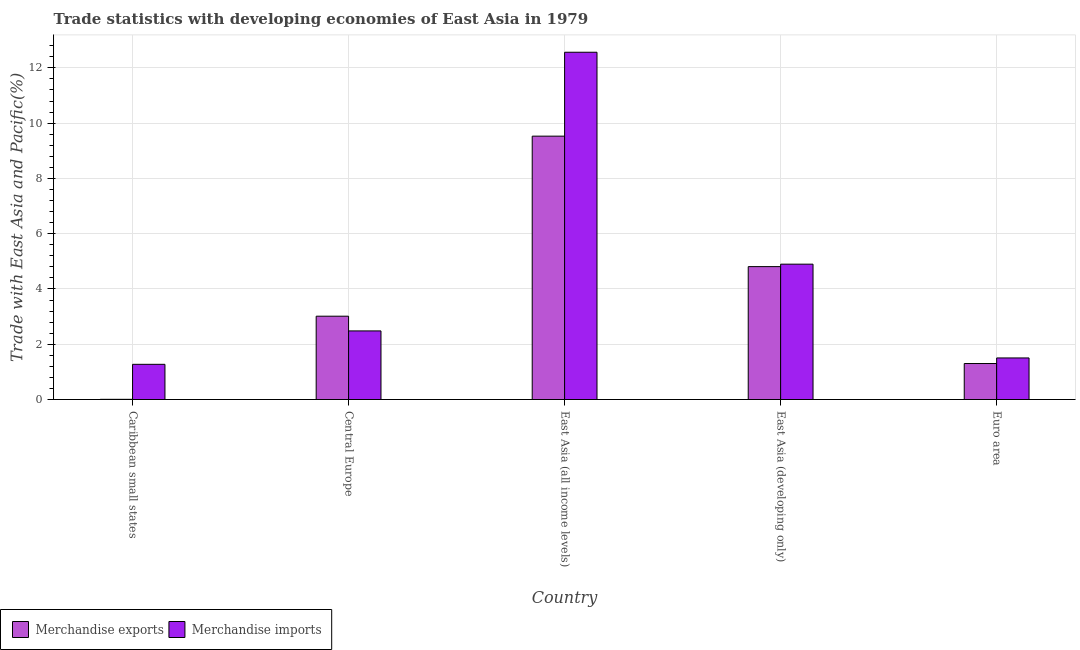Are the number of bars per tick equal to the number of legend labels?
Offer a terse response. Yes. Are the number of bars on each tick of the X-axis equal?
Make the answer very short. Yes. In how many cases, is the number of bars for a given country not equal to the number of legend labels?
Give a very brief answer. 0. What is the merchandise exports in Euro area?
Provide a short and direct response. 1.3. Across all countries, what is the maximum merchandise exports?
Ensure brevity in your answer.  9.53. Across all countries, what is the minimum merchandise exports?
Give a very brief answer. 0.01. In which country was the merchandise imports maximum?
Your answer should be compact. East Asia (all income levels). In which country was the merchandise imports minimum?
Offer a terse response. Caribbean small states. What is the total merchandise imports in the graph?
Provide a succinct answer. 22.72. What is the difference between the merchandise exports in Central Europe and that in Euro area?
Your answer should be very brief. 1.71. What is the difference between the merchandise imports in East Asia (all income levels) and the merchandise exports in Caribbean small states?
Your answer should be very brief. 12.56. What is the average merchandise exports per country?
Your answer should be very brief. 3.73. What is the difference between the merchandise exports and merchandise imports in Caribbean small states?
Your answer should be very brief. -1.27. What is the ratio of the merchandise imports in Caribbean small states to that in East Asia (all income levels)?
Give a very brief answer. 0.1. Is the merchandise exports in East Asia (developing only) less than that in Euro area?
Give a very brief answer. No. Is the difference between the merchandise exports in East Asia (all income levels) and East Asia (developing only) greater than the difference between the merchandise imports in East Asia (all income levels) and East Asia (developing only)?
Provide a succinct answer. No. What is the difference between the highest and the second highest merchandise imports?
Your answer should be compact. 7.67. What is the difference between the highest and the lowest merchandise imports?
Give a very brief answer. 11.29. In how many countries, is the merchandise exports greater than the average merchandise exports taken over all countries?
Make the answer very short. 2. How many bars are there?
Make the answer very short. 10. How many countries are there in the graph?
Provide a succinct answer. 5. Where does the legend appear in the graph?
Offer a very short reply. Bottom left. How many legend labels are there?
Your answer should be very brief. 2. How are the legend labels stacked?
Offer a very short reply. Horizontal. What is the title of the graph?
Provide a succinct answer. Trade statistics with developing economies of East Asia in 1979. What is the label or title of the X-axis?
Offer a terse response. Country. What is the label or title of the Y-axis?
Ensure brevity in your answer.  Trade with East Asia and Pacific(%). What is the Trade with East Asia and Pacific(%) in Merchandise exports in Caribbean small states?
Give a very brief answer. 0.01. What is the Trade with East Asia and Pacific(%) of Merchandise imports in Caribbean small states?
Your answer should be very brief. 1.27. What is the Trade with East Asia and Pacific(%) of Merchandise exports in Central Europe?
Keep it short and to the point. 3.02. What is the Trade with East Asia and Pacific(%) of Merchandise imports in Central Europe?
Provide a short and direct response. 2.48. What is the Trade with East Asia and Pacific(%) in Merchandise exports in East Asia (all income levels)?
Ensure brevity in your answer.  9.53. What is the Trade with East Asia and Pacific(%) in Merchandise imports in East Asia (all income levels)?
Your answer should be very brief. 12.57. What is the Trade with East Asia and Pacific(%) in Merchandise exports in East Asia (developing only)?
Offer a terse response. 4.81. What is the Trade with East Asia and Pacific(%) of Merchandise imports in East Asia (developing only)?
Provide a short and direct response. 4.9. What is the Trade with East Asia and Pacific(%) in Merchandise exports in Euro area?
Your answer should be very brief. 1.3. What is the Trade with East Asia and Pacific(%) in Merchandise imports in Euro area?
Offer a terse response. 1.5. Across all countries, what is the maximum Trade with East Asia and Pacific(%) in Merchandise exports?
Offer a terse response. 9.53. Across all countries, what is the maximum Trade with East Asia and Pacific(%) of Merchandise imports?
Make the answer very short. 12.57. Across all countries, what is the minimum Trade with East Asia and Pacific(%) in Merchandise exports?
Your response must be concise. 0.01. Across all countries, what is the minimum Trade with East Asia and Pacific(%) in Merchandise imports?
Make the answer very short. 1.27. What is the total Trade with East Asia and Pacific(%) of Merchandise exports in the graph?
Ensure brevity in your answer.  18.66. What is the total Trade with East Asia and Pacific(%) in Merchandise imports in the graph?
Ensure brevity in your answer.  22.72. What is the difference between the Trade with East Asia and Pacific(%) in Merchandise exports in Caribbean small states and that in Central Europe?
Your answer should be compact. -3.01. What is the difference between the Trade with East Asia and Pacific(%) of Merchandise imports in Caribbean small states and that in Central Europe?
Ensure brevity in your answer.  -1.21. What is the difference between the Trade with East Asia and Pacific(%) of Merchandise exports in Caribbean small states and that in East Asia (all income levels)?
Keep it short and to the point. -9.52. What is the difference between the Trade with East Asia and Pacific(%) in Merchandise imports in Caribbean small states and that in East Asia (all income levels)?
Keep it short and to the point. -11.29. What is the difference between the Trade with East Asia and Pacific(%) of Merchandise exports in Caribbean small states and that in East Asia (developing only)?
Your response must be concise. -4.8. What is the difference between the Trade with East Asia and Pacific(%) in Merchandise imports in Caribbean small states and that in East Asia (developing only)?
Give a very brief answer. -3.62. What is the difference between the Trade with East Asia and Pacific(%) of Merchandise exports in Caribbean small states and that in Euro area?
Offer a very short reply. -1.3. What is the difference between the Trade with East Asia and Pacific(%) of Merchandise imports in Caribbean small states and that in Euro area?
Your answer should be compact. -0.23. What is the difference between the Trade with East Asia and Pacific(%) of Merchandise exports in Central Europe and that in East Asia (all income levels)?
Your response must be concise. -6.51. What is the difference between the Trade with East Asia and Pacific(%) of Merchandise imports in Central Europe and that in East Asia (all income levels)?
Make the answer very short. -10.08. What is the difference between the Trade with East Asia and Pacific(%) of Merchandise exports in Central Europe and that in East Asia (developing only)?
Offer a very short reply. -1.79. What is the difference between the Trade with East Asia and Pacific(%) in Merchandise imports in Central Europe and that in East Asia (developing only)?
Provide a short and direct response. -2.41. What is the difference between the Trade with East Asia and Pacific(%) of Merchandise exports in Central Europe and that in Euro area?
Offer a very short reply. 1.71. What is the difference between the Trade with East Asia and Pacific(%) of Merchandise imports in Central Europe and that in Euro area?
Your response must be concise. 0.98. What is the difference between the Trade with East Asia and Pacific(%) of Merchandise exports in East Asia (all income levels) and that in East Asia (developing only)?
Your answer should be very brief. 4.72. What is the difference between the Trade with East Asia and Pacific(%) in Merchandise imports in East Asia (all income levels) and that in East Asia (developing only)?
Your response must be concise. 7.67. What is the difference between the Trade with East Asia and Pacific(%) of Merchandise exports in East Asia (all income levels) and that in Euro area?
Provide a succinct answer. 8.23. What is the difference between the Trade with East Asia and Pacific(%) of Merchandise imports in East Asia (all income levels) and that in Euro area?
Provide a short and direct response. 11.06. What is the difference between the Trade with East Asia and Pacific(%) of Merchandise exports in East Asia (developing only) and that in Euro area?
Give a very brief answer. 3.51. What is the difference between the Trade with East Asia and Pacific(%) of Merchandise imports in East Asia (developing only) and that in Euro area?
Ensure brevity in your answer.  3.39. What is the difference between the Trade with East Asia and Pacific(%) of Merchandise exports in Caribbean small states and the Trade with East Asia and Pacific(%) of Merchandise imports in Central Europe?
Make the answer very short. -2.48. What is the difference between the Trade with East Asia and Pacific(%) of Merchandise exports in Caribbean small states and the Trade with East Asia and Pacific(%) of Merchandise imports in East Asia (all income levels)?
Ensure brevity in your answer.  -12.56. What is the difference between the Trade with East Asia and Pacific(%) of Merchandise exports in Caribbean small states and the Trade with East Asia and Pacific(%) of Merchandise imports in East Asia (developing only)?
Make the answer very short. -4.89. What is the difference between the Trade with East Asia and Pacific(%) in Merchandise exports in Caribbean small states and the Trade with East Asia and Pacific(%) in Merchandise imports in Euro area?
Make the answer very short. -1.5. What is the difference between the Trade with East Asia and Pacific(%) of Merchandise exports in Central Europe and the Trade with East Asia and Pacific(%) of Merchandise imports in East Asia (all income levels)?
Provide a succinct answer. -9.55. What is the difference between the Trade with East Asia and Pacific(%) in Merchandise exports in Central Europe and the Trade with East Asia and Pacific(%) in Merchandise imports in East Asia (developing only)?
Your response must be concise. -1.88. What is the difference between the Trade with East Asia and Pacific(%) in Merchandise exports in Central Europe and the Trade with East Asia and Pacific(%) in Merchandise imports in Euro area?
Offer a very short reply. 1.51. What is the difference between the Trade with East Asia and Pacific(%) in Merchandise exports in East Asia (all income levels) and the Trade with East Asia and Pacific(%) in Merchandise imports in East Asia (developing only)?
Offer a terse response. 4.63. What is the difference between the Trade with East Asia and Pacific(%) in Merchandise exports in East Asia (all income levels) and the Trade with East Asia and Pacific(%) in Merchandise imports in Euro area?
Provide a succinct answer. 8.03. What is the difference between the Trade with East Asia and Pacific(%) of Merchandise exports in East Asia (developing only) and the Trade with East Asia and Pacific(%) of Merchandise imports in Euro area?
Give a very brief answer. 3.3. What is the average Trade with East Asia and Pacific(%) in Merchandise exports per country?
Your answer should be very brief. 3.73. What is the average Trade with East Asia and Pacific(%) of Merchandise imports per country?
Your answer should be compact. 4.54. What is the difference between the Trade with East Asia and Pacific(%) of Merchandise exports and Trade with East Asia and Pacific(%) of Merchandise imports in Caribbean small states?
Your response must be concise. -1.27. What is the difference between the Trade with East Asia and Pacific(%) in Merchandise exports and Trade with East Asia and Pacific(%) in Merchandise imports in Central Europe?
Give a very brief answer. 0.53. What is the difference between the Trade with East Asia and Pacific(%) of Merchandise exports and Trade with East Asia and Pacific(%) of Merchandise imports in East Asia (all income levels)?
Offer a very short reply. -3.04. What is the difference between the Trade with East Asia and Pacific(%) in Merchandise exports and Trade with East Asia and Pacific(%) in Merchandise imports in East Asia (developing only)?
Ensure brevity in your answer.  -0.09. What is the difference between the Trade with East Asia and Pacific(%) of Merchandise exports and Trade with East Asia and Pacific(%) of Merchandise imports in Euro area?
Provide a short and direct response. -0.2. What is the ratio of the Trade with East Asia and Pacific(%) in Merchandise exports in Caribbean small states to that in Central Europe?
Provide a short and direct response. 0. What is the ratio of the Trade with East Asia and Pacific(%) of Merchandise imports in Caribbean small states to that in Central Europe?
Keep it short and to the point. 0.51. What is the ratio of the Trade with East Asia and Pacific(%) in Merchandise exports in Caribbean small states to that in East Asia (all income levels)?
Provide a succinct answer. 0. What is the ratio of the Trade with East Asia and Pacific(%) in Merchandise imports in Caribbean small states to that in East Asia (all income levels)?
Make the answer very short. 0.1. What is the ratio of the Trade with East Asia and Pacific(%) in Merchandise exports in Caribbean small states to that in East Asia (developing only)?
Your answer should be compact. 0. What is the ratio of the Trade with East Asia and Pacific(%) of Merchandise imports in Caribbean small states to that in East Asia (developing only)?
Your answer should be compact. 0.26. What is the ratio of the Trade with East Asia and Pacific(%) in Merchandise exports in Caribbean small states to that in Euro area?
Provide a short and direct response. 0.01. What is the ratio of the Trade with East Asia and Pacific(%) of Merchandise imports in Caribbean small states to that in Euro area?
Give a very brief answer. 0.85. What is the ratio of the Trade with East Asia and Pacific(%) of Merchandise exports in Central Europe to that in East Asia (all income levels)?
Keep it short and to the point. 0.32. What is the ratio of the Trade with East Asia and Pacific(%) in Merchandise imports in Central Europe to that in East Asia (all income levels)?
Offer a terse response. 0.2. What is the ratio of the Trade with East Asia and Pacific(%) of Merchandise exports in Central Europe to that in East Asia (developing only)?
Offer a very short reply. 0.63. What is the ratio of the Trade with East Asia and Pacific(%) in Merchandise imports in Central Europe to that in East Asia (developing only)?
Your answer should be compact. 0.51. What is the ratio of the Trade with East Asia and Pacific(%) in Merchandise exports in Central Europe to that in Euro area?
Your answer should be compact. 2.31. What is the ratio of the Trade with East Asia and Pacific(%) of Merchandise imports in Central Europe to that in Euro area?
Make the answer very short. 1.65. What is the ratio of the Trade with East Asia and Pacific(%) in Merchandise exports in East Asia (all income levels) to that in East Asia (developing only)?
Provide a succinct answer. 1.98. What is the ratio of the Trade with East Asia and Pacific(%) of Merchandise imports in East Asia (all income levels) to that in East Asia (developing only)?
Give a very brief answer. 2.57. What is the ratio of the Trade with East Asia and Pacific(%) in Merchandise exports in East Asia (all income levels) to that in Euro area?
Make the answer very short. 7.32. What is the ratio of the Trade with East Asia and Pacific(%) of Merchandise imports in East Asia (all income levels) to that in Euro area?
Ensure brevity in your answer.  8.35. What is the ratio of the Trade with East Asia and Pacific(%) in Merchandise exports in East Asia (developing only) to that in Euro area?
Make the answer very short. 3.69. What is the ratio of the Trade with East Asia and Pacific(%) in Merchandise imports in East Asia (developing only) to that in Euro area?
Your answer should be very brief. 3.25. What is the difference between the highest and the second highest Trade with East Asia and Pacific(%) in Merchandise exports?
Offer a terse response. 4.72. What is the difference between the highest and the second highest Trade with East Asia and Pacific(%) in Merchandise imports?
Provide a short and direct response. 7.67. What is the difference between the highest and the lowest Trade with East Asia and Pacific(%) of Merchandise exports?
Ensure brevity in your answer.  9.52. What is the difference between the highest and the lowest Trade with East Asia and Pacific(%) in Merchandise imports?
Provide a succinct answer. 11.29. 